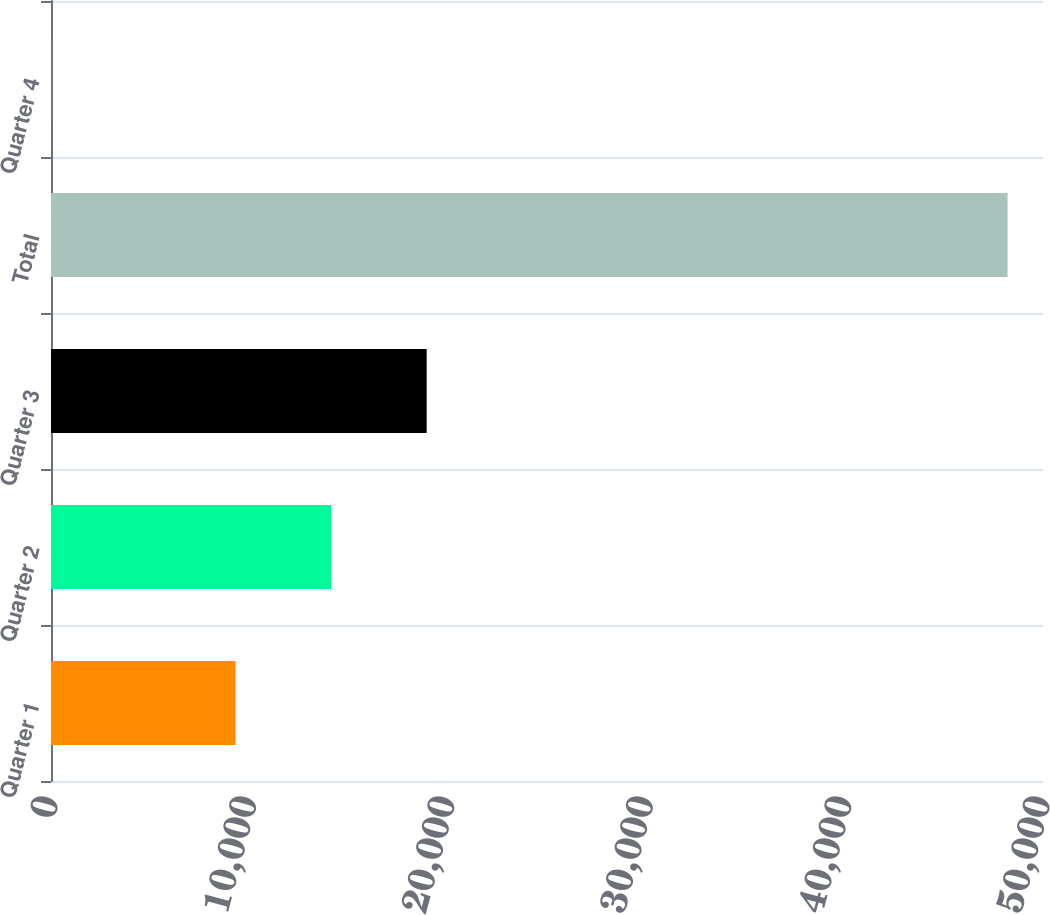<chart> <loc_0><loc_0><loc_500><loc_500><bar_chart><fcel>Quarter 1<fcel>Quarter 2<fcel>Quarter 3<fcel>Total<fcel>Quarter 4<nl><fcel>9295<fcel>14115.6<fcel>18936.2<fcel>48214<fcel>7.8<nl></chart> 